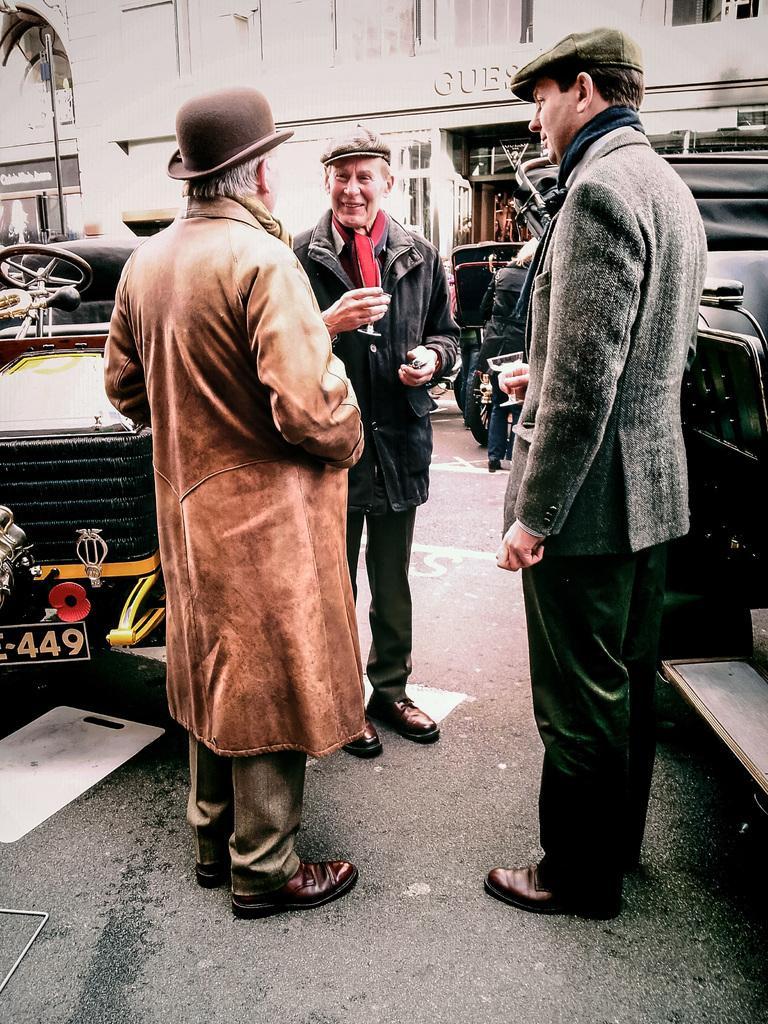Describe this image in one or two sentences. As we can see in the image there are few people here and there, vehicles and buildings. 